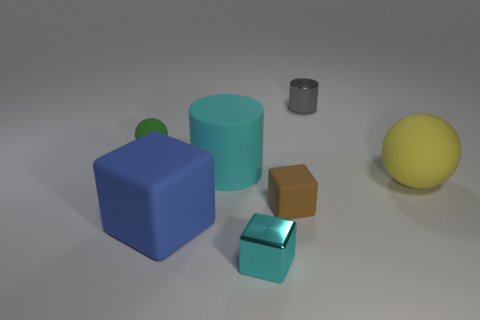Add 3 large green matte objects. How many objects exist? 10 Subtract all blocks. How many objects are left? 4 Subtract 1 gray cylinders. How many objects are left? 6 Subtract all red matte things. Subtract all cyan rubber things. How many objects are left? 6 Add 3 metallic things. How many metallic things are left? 5 Add 3 small blue matte cylinders. How many small blue matte cylinders exist? 3 